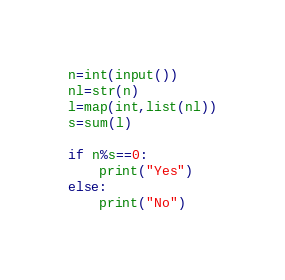<code> <loc_0><loc_0><loc_500><loc_500><_Python_>n=int(input())
nl=str(n)
l=map(int,list(nl))
s=sum(l)

if n%s==0:
    print("Yes")
else:
    print("No")
</code> 